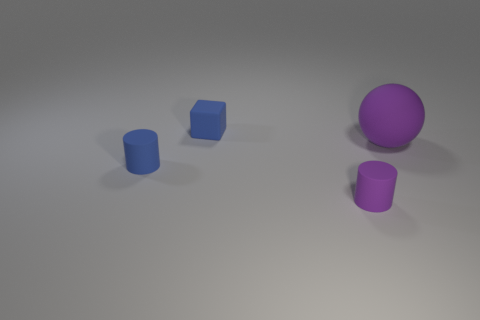What is the shape of the large thing that is to the right of the tiny purple thing?
Make the answer very short. Sphere. Do the big purple sphere and the small blue cylinder have the same material?
Your answer should be very brief. Yes. Are there any other things that are the same size as the matte sphere?
Provide a succinct answer. No. How many tiny blue matte cylinders are to the left of the blue cube?
Keep it short and to the point. 1. There is a purple object that is behind the tiny blue matte thing on the left side of the small matte block; what is its shape?
Offer a very short reply. Sphere. Are there any other things that are the same shape as the big matte object?
Make the answer very short. No. Are there more tiny matte objects to the left of the big thing than yellow matte objects?
Provide a short and direct response. Yes. There is a tiny thing behind the big purple object; what number of cubes are behind it?
Give a very brief answer. 0. What is the shape of the tiny object that is to the right of the blue thing that is to the right of the cylinder on the left side of the tiny purple cylinder?
Keep it short and to the point. Cylinder. What is the size of the purple rubber sphere?
Give a very brief answer. Large. 